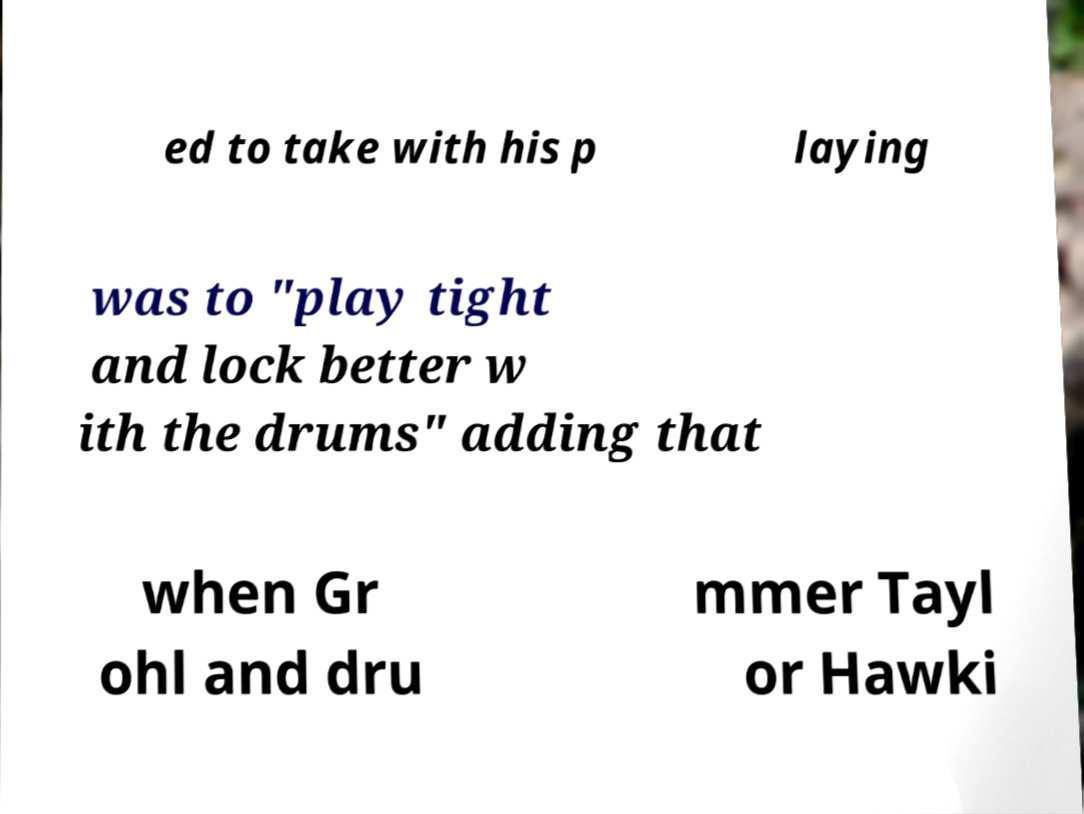For documentation purposes, I need the text within this image transcribed. Could you provide that? ed to take with his p laying was to "play tight and lock better w ith the drums" adding that when Gr ohl and dru mmer Tayl or Hawki 